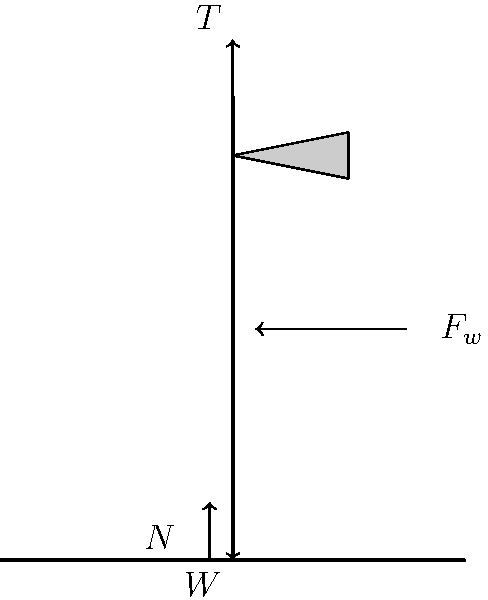As the embassy's public relations officer, you're tasked with explaining the stability of the flagpole during high winds to local media. Using the free-body diagram provided, which shows a flagpole subject to wind force ($F_w$), tension ($T$), weight ($W$), and normal force ($N$), explain how these forces interact to keep the flagpole upright. What condition must be met for the flagpole to remain stable? To explain the stability of the flagpole to the media, we need to consider the forces acting on it and their balance:

1. Vertical forces:
   - Weight ($W$): Acts downward due to gravity.
   - Tension ($T$): Acts upward, provided by the flagpole's structural integrity.
   - Normal force ($N$): Acts upward from the ground, supporting the flagpole.

   For vertical stability: $T + N = W$

2. Horizontal forces:
   - Wind force ($F_w$): Acts horizontally, trying to topple the flagpole.
   - Friction and structural resistance (not shown in diagram): Counteract the wind force.

3. Rotational stability:
   - The wind force creates a torque around the base of the flagpole.
   - This torque is countered by the flagpole's weight and its anchoring system.

4. Stability condition:
   The sum of moments resisting rotation must be greater than or equal to the moment caused by the wind force.

   Mathematically: $M_{resisting} \geq M_{wind}$

   Where $M_{resisting}$ includes the moment due to the flagpole's weight and any additional anchoring, and $M_{wind}$ is the moment caused by the wind force.

5. For the flagpole to remain upright:
   - The vertical forces must be balanced: $T + N = W$
   - The horizontal forces must be balanced by structural integrity and anchoring.
   - The resisting moment must be greater than or equal to the wind's moment: $M_{resisting} \geq M_{wind}$

If these conditions are met, the flagpole will remain stable even in high winds.
Answer: $M_{resisting} \geq M_{wind}$ and $T + N = W$ 